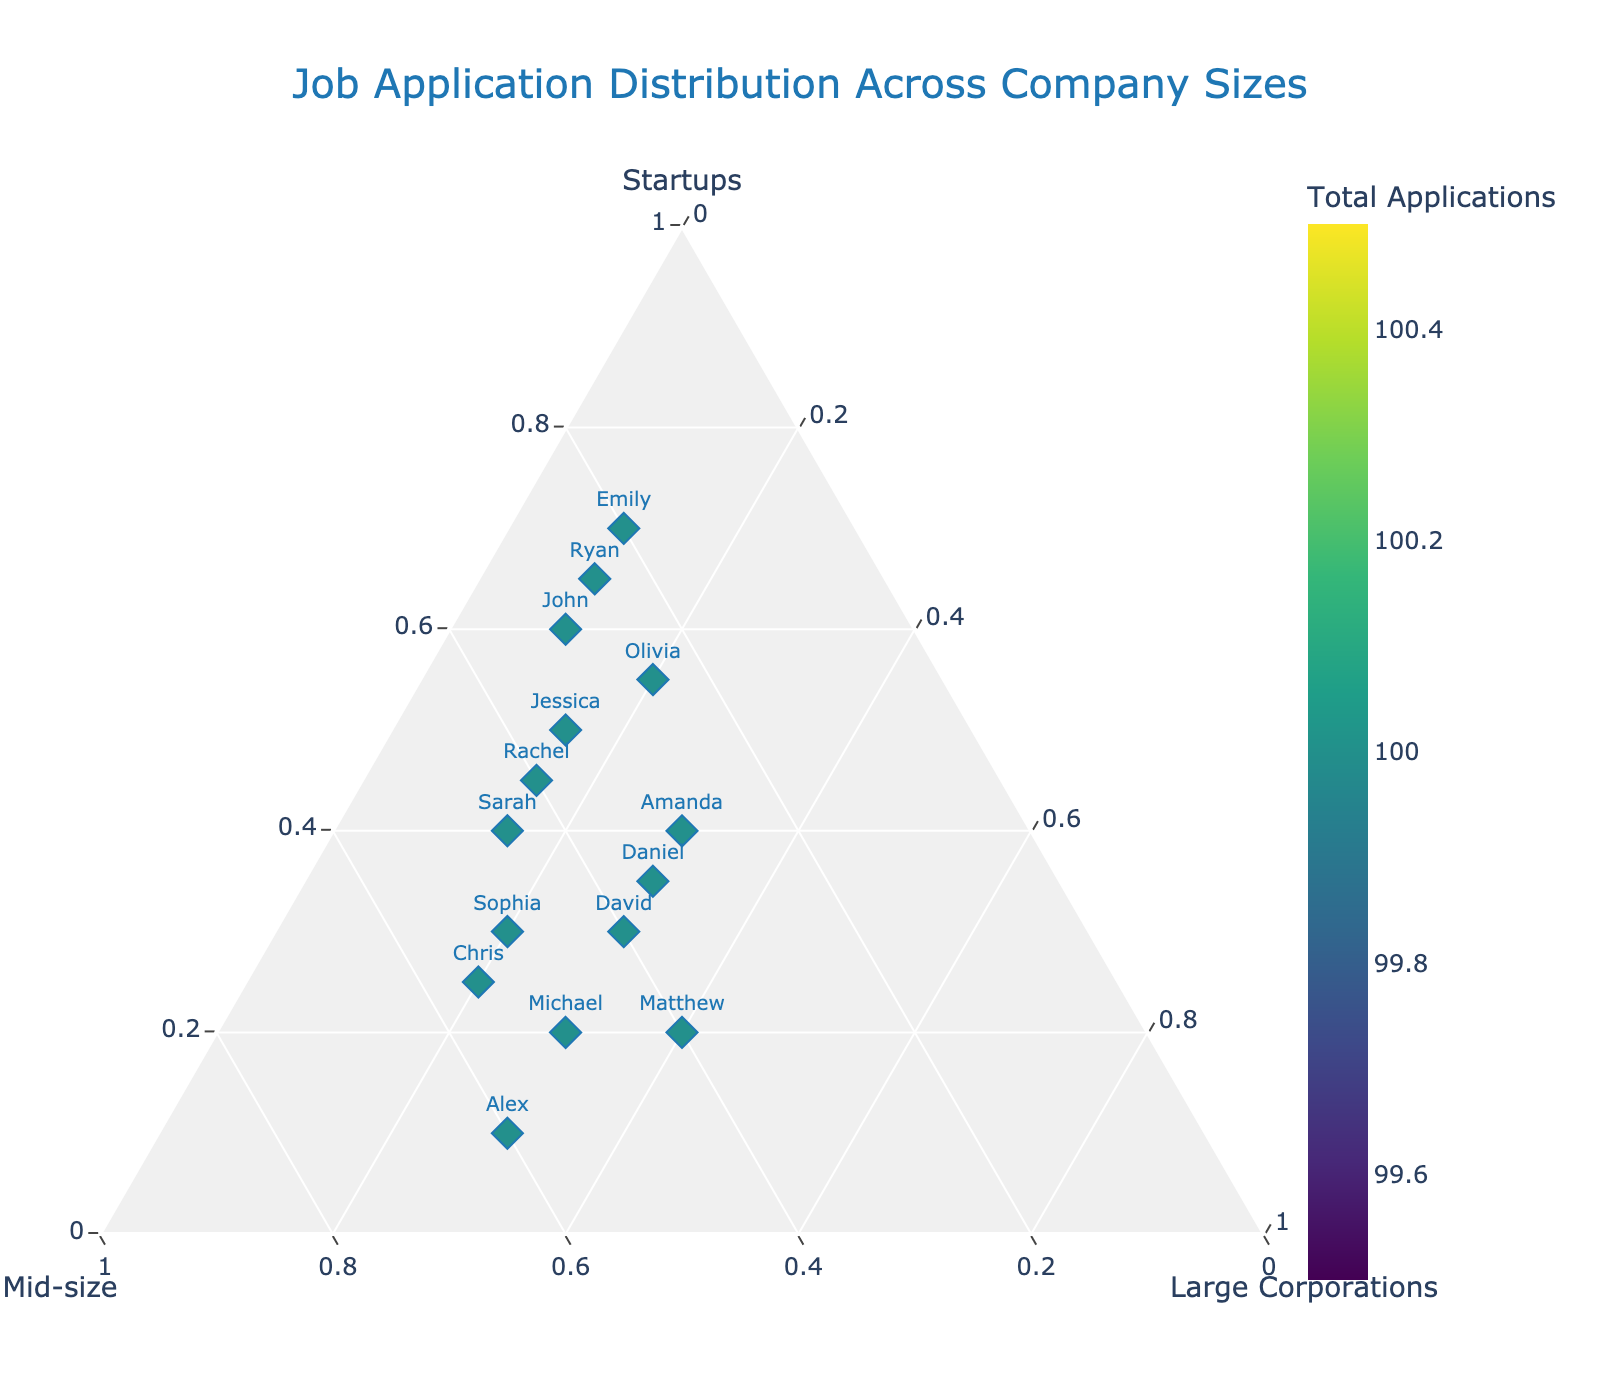Which applicant applied to the highest percentage of startups? From the figure, look for the data point closest to the 'Startups' axis, which represents the highest percentage for startups. The applicant represented by this point has applied to the highest percentage of startups.
Answer: Emily Which applicant applied to an equal percentage of mid-size and large corporations? Check for a point where the percentages of mid-size and large corporations are the same. The `hovertemplate` indicates this information.
Answer: Amanda How many total applications did Jessica submit? Use the color bar to approximate the color of Jessica's marker, which represents the total applications submitted by her.
Answer: 100 Who applied to all three types of companies in nearly equal proportions? Find the data points closest to the center of the ternary plot, as these represent applicants who applied in nearly equal proportions to all three company types.
Answer: David and Daniel Which company size did John apply the least to? Examine the hover details for John. The percentages for startups, mid-size, and large corporations are shown, allowing you to determine the smallest percentage.
Answer: Large Corporations Which applicant's application distribution is most evenly spread among the three company sizes? Look at the markers near the center of the ternary plot, where applicants would have the most evenly distributed applications.
Answer: Daniel How many applicants are there in the plot? Count the total number of unique data points or markers on the plot, each representing one applicant.
Answer: 15 What is the common color scheme used in the plot? Note the overall color gradient and the specific colors used in the colorbar that represents the total number of applications.
Answer: Viridis 